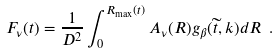Convert formula to latex. <formula><loc_0><loc_0><loc_500><loc_500>F _ { \nu } ( t ) = \frac { 1 } { D ^ { 2 } } \int _ { 0 } ^ { R _ { \max } ( t ) } A _ { \nu } ( R ) g _ { \beta } ( \widetilde { t } , k ) d R \ .</formula> 